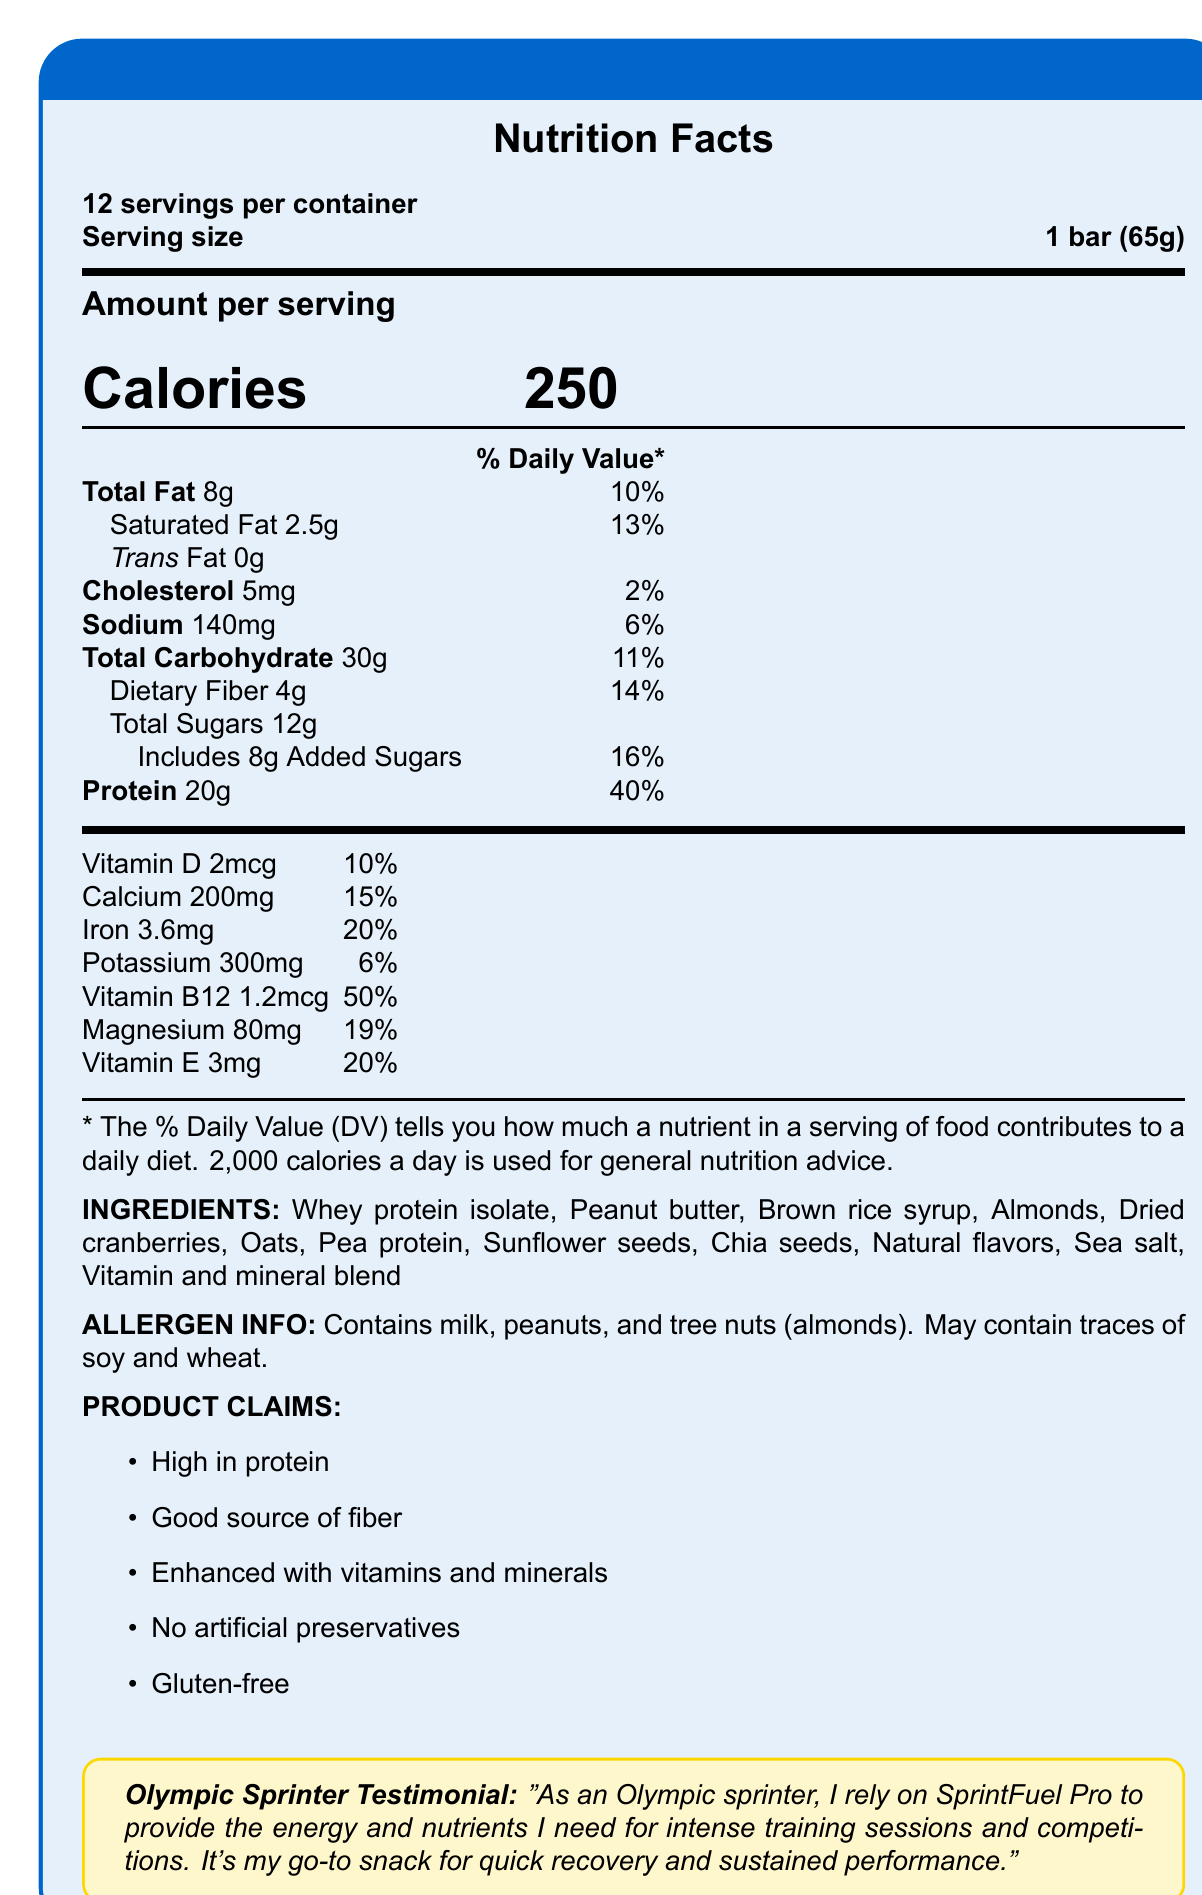how many servings are in a container? The document states there are 12 servings per container under the heading "Nutrition Facts."
Answer: 12 What is the serving size of the SprintFuel Pro Energy Bar? The serving size is listed as "1 bar (65g)" right below the number of servings per container in the Nutrition Facts section.
Answer: 1 bar (65g) how much protein does one serving contain? The protein content per serving is listed as "20g" in the Nutrition Facts section.
Answer: 20g What percentage of the daily value of Vitamin B12 does one bar provide? The document lists the daily value of Vitamin B12 as 50% in the vitamins and minerals section.
Answer: 50% What allergens are present in the SprintFuel Pro Energy Bar? The allergen information section states that the bar contains milk, peanuts, and tree nuts (almonds).
Answer: Milk, peanuts, and tree nuts (almonds) How many calories are in one serving of the SprintFuel Pro Energy Bar? The Nutrition Facts section indicates that there are 250 calories per serving.
Answer: 250 What claim is made about the preservatives in the SprintFuel Pro Energy Bar? The product claims section lists "No artificial preservatives."
Answer: No artificial preservatives Which of the following is NOT listed as an ingredient in the SprintFuel Pro Energy Bar? A. Almonds B. Dried cranberries C. Coconut D. Oats The ingredient list does not mention coconut; it includes almonds, dried cranberries, and oats.
Answer: C. Coconut What is the percentage of daily value for iron in one bar? The daily value of iron is listed as 20% in the Nutrition Facts section.
Answer: 20% What is the source of the testimonial in the document? The testimonial box states that it is from an Olympic sprinter, who talks about relying on SprintFuel Pro.
Answer: An Olympic sprinter True or False: The SprintFuel Pro Energy Bar includes artificial colors. The document specifies the product claims to have "No artificial preservatives," and there's no mention of artificial colors in the ingredient list or claims.
Answer: False Summarize the main idea of the document. The document provides comprehensive nutritional information, including serving size, calories, protein, and essential vitamins and minerals. It lists the ingredients and allergens and highlights product claims such as being high in protein and gluten-free. An Olympic sprinter's testimonial emphasizes the product's benefits for training and performance.
Answer: The document describes the nutritional content, ingredients, allergens, and product claims of the SprintFuel Pro Energy Bar, which is designed for athletes with enhanced vitamins and protein. It includes a testimonial from an Olympic sprinter endorsing the product for energy and recovery. Which vitamin has the highest daily value percentage in one bar? The document indicates that Vitamin B12 provides 50% of the daily value per bar, which is higher than any other vitamin listed.
Answer: Vitamin B12 How much sodium does one serving contain? The Nutrition Facts section lists the sodium content as 140mg per serving.
Answer: 140mg What are the main sources of protein in the SprintFuel Pro Energy Bar? The ingredients list includes whey protein isolate and pea protein as the main sources of protein.
Answer: Whey protein isolate and pea protein What’s the percentage of daily value for dietary fiber provided by one bar? The Nutrition Facts section lists the dietary fiber content as 4g, which is 14% of the daily value.
Answer: 14% Can you determine the price of the SprintFuel Pro Energy Bar from the document? The document contains nutritional information, ingredients, allergens, and product claims but does not mention the price of the bar.
Answer: Cannot be determined 